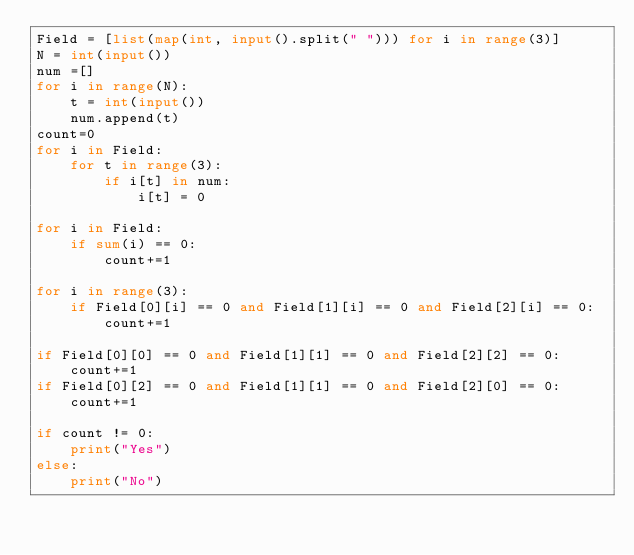<code> <loc_0><loc_0><loc_500><loc_500><_Python_>Field = [list(map(int, input().split(" "))) for i in range(3)]
N = int(input())
num =[]
for i in range(N):
    t = int(input())
    num.append(t)
count=0
for i in Field:
    for t in range(3):
        if i[t] in num:
            i[t] = 0

for i in Field:
    if sum(i) == 0:
        count+=1

for i in range(3):
    if Field[0][i] == 0 and Field[1][i] == 0 and Field[2][i] == 0:
        count+=1

if Field[0][0] == 0 and Field[1][1] == 0 and Field[2][2] == 0:
    count+=1
if Field[0][2] == 0 and Field[1][1] == 0 and Field[2][0] == 0:
    count+=1

if count != 0:
    print("Yes")
else:
    print("No")
</code> 